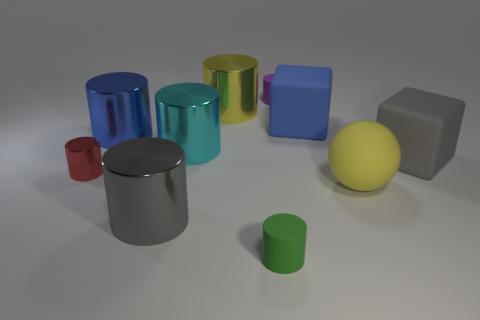Subtract all tiny red cylinders. How many cylinders are left? 6 Subtract all gray cylinders. How many cylinders are left? 6 Subtract all purple blocks. Subtract all cyan cylinders. How many blocks are left? 2 Subtract all big cyan objects. Subtract all red metal objects. How many objects are left? 8 Add 5 green rubber cylinders. How many green rubber cylinders are left? 6 Add 1 green objects. How many green objects exist? 2 Subtract 0 brown cylinders. How many objects are left? 10 Subtract all cylinders. How many objects are left? 3 